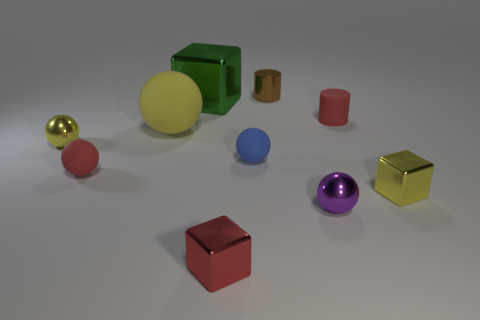How many objects are small red shiny things or gray matte balls? In the image, there is one small red shiny cube and no gray matte balls, making the total count one. 